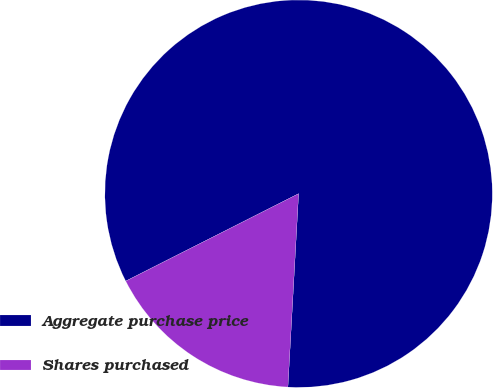Convert chart to OTSL. <chart><loc_0><loc_0><loc_500><loc_500><pie_chart><fcel>Aggregate purchase price<fcel>Shares purchased<nl><fcel>83.33%<fcel>16.67%<nl></chart> 